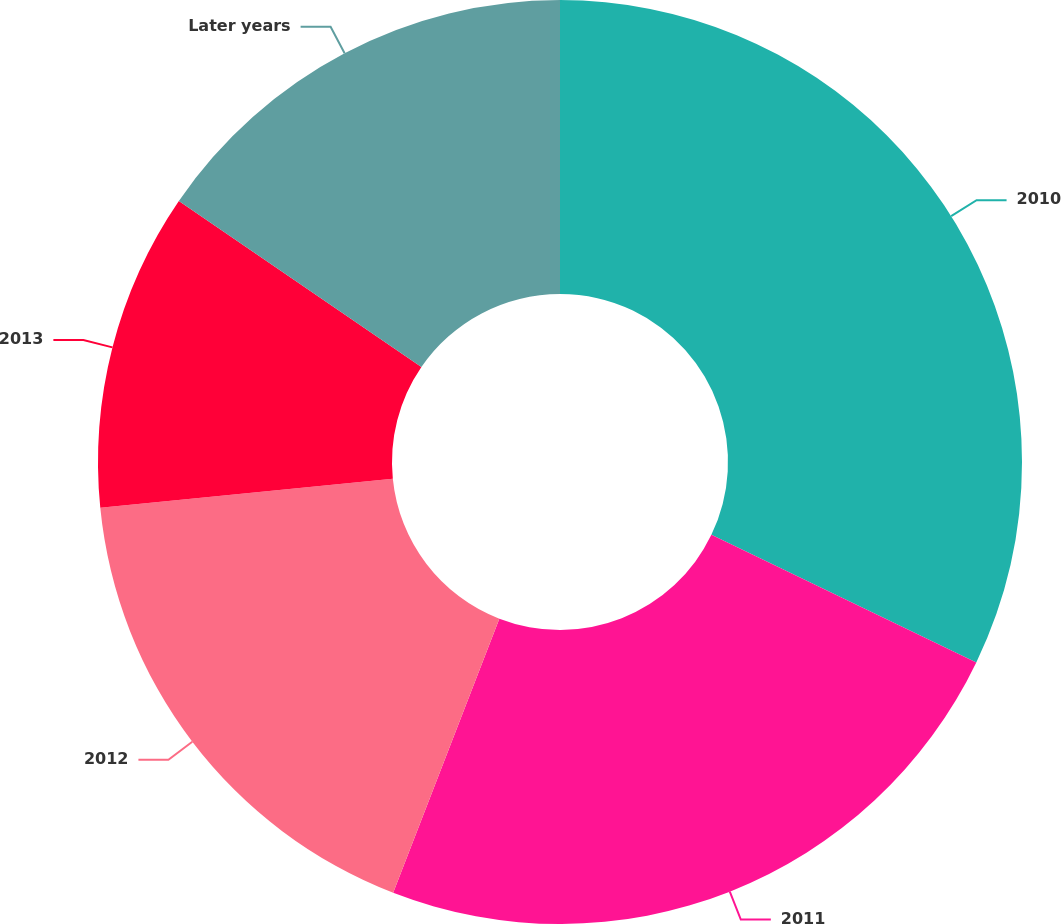Convert chart. <chart><loc_0><loc_0><loc_500><loc_500><pie_chart><fcel>2010<fcel>2011<fcel>2012<fcel>2013<fcel>Later years<nl><fcel>32.14%<fcel>23.74%<fcel>17.54%<fcel>11.14%<fcel>15.44%<nl></chart> 